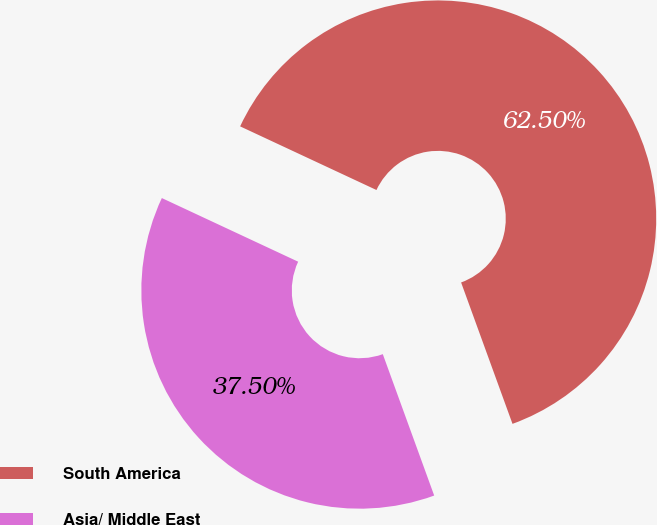Convert chart. <chart><loc_0><loc_0><loc_500><loc_500><pie_chart><fcel>South America<fcel>Asia/ Middle East<nl><fcel>62.5%<fcel>37.5%<nl></chart> 